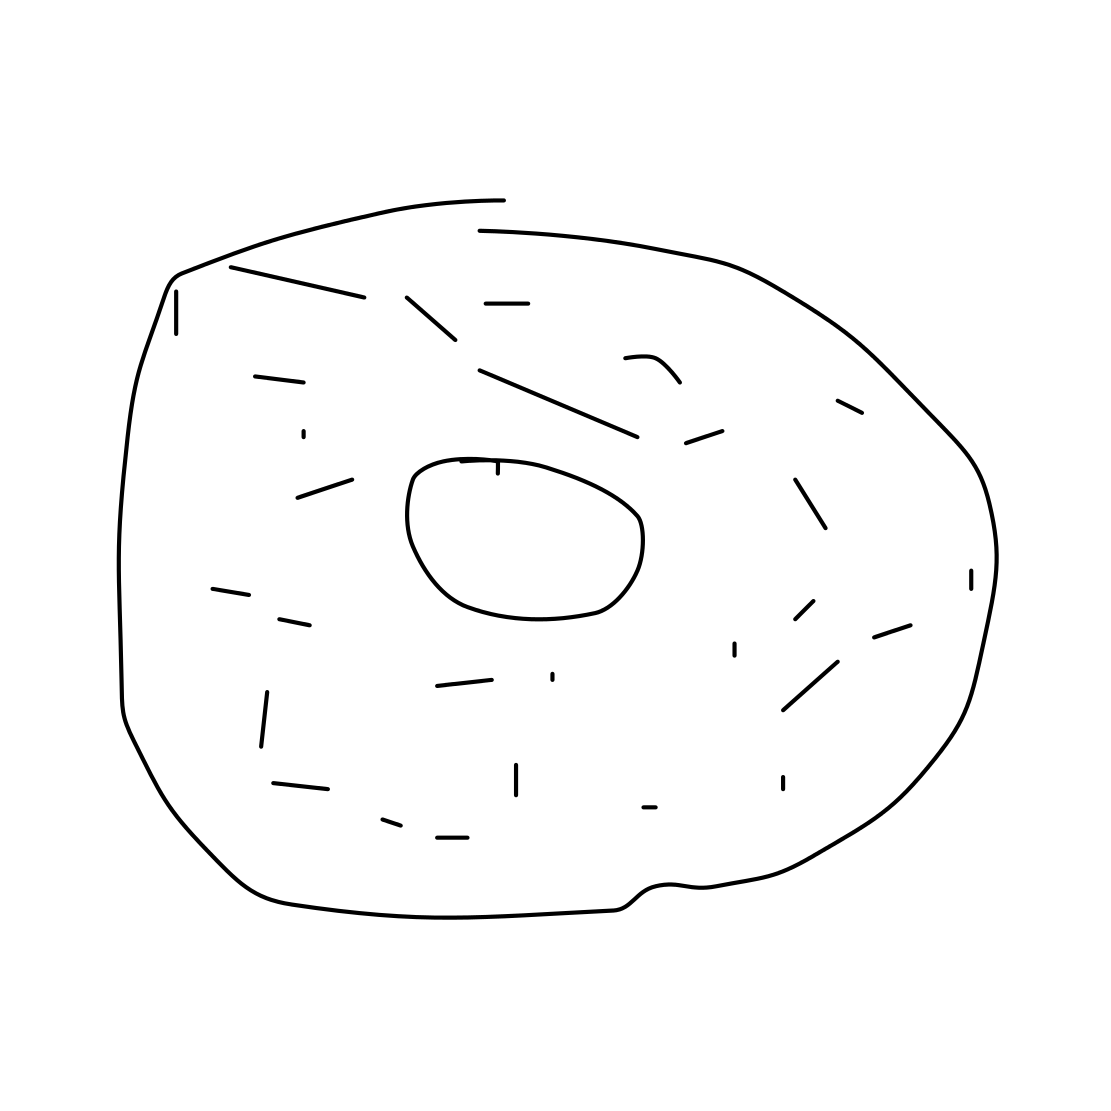What toppings could be added to this donut to make it more enticing? To make this basic donut more appealing, one could consider adding a variety of toppings such as colorful sprinkles, a rich chocolate glaze, a dusting of powdered sugar, or a drizzle of caramel. Creativity is key with donuts, so even fruits or candy pieces could serve to make it more enticing. 